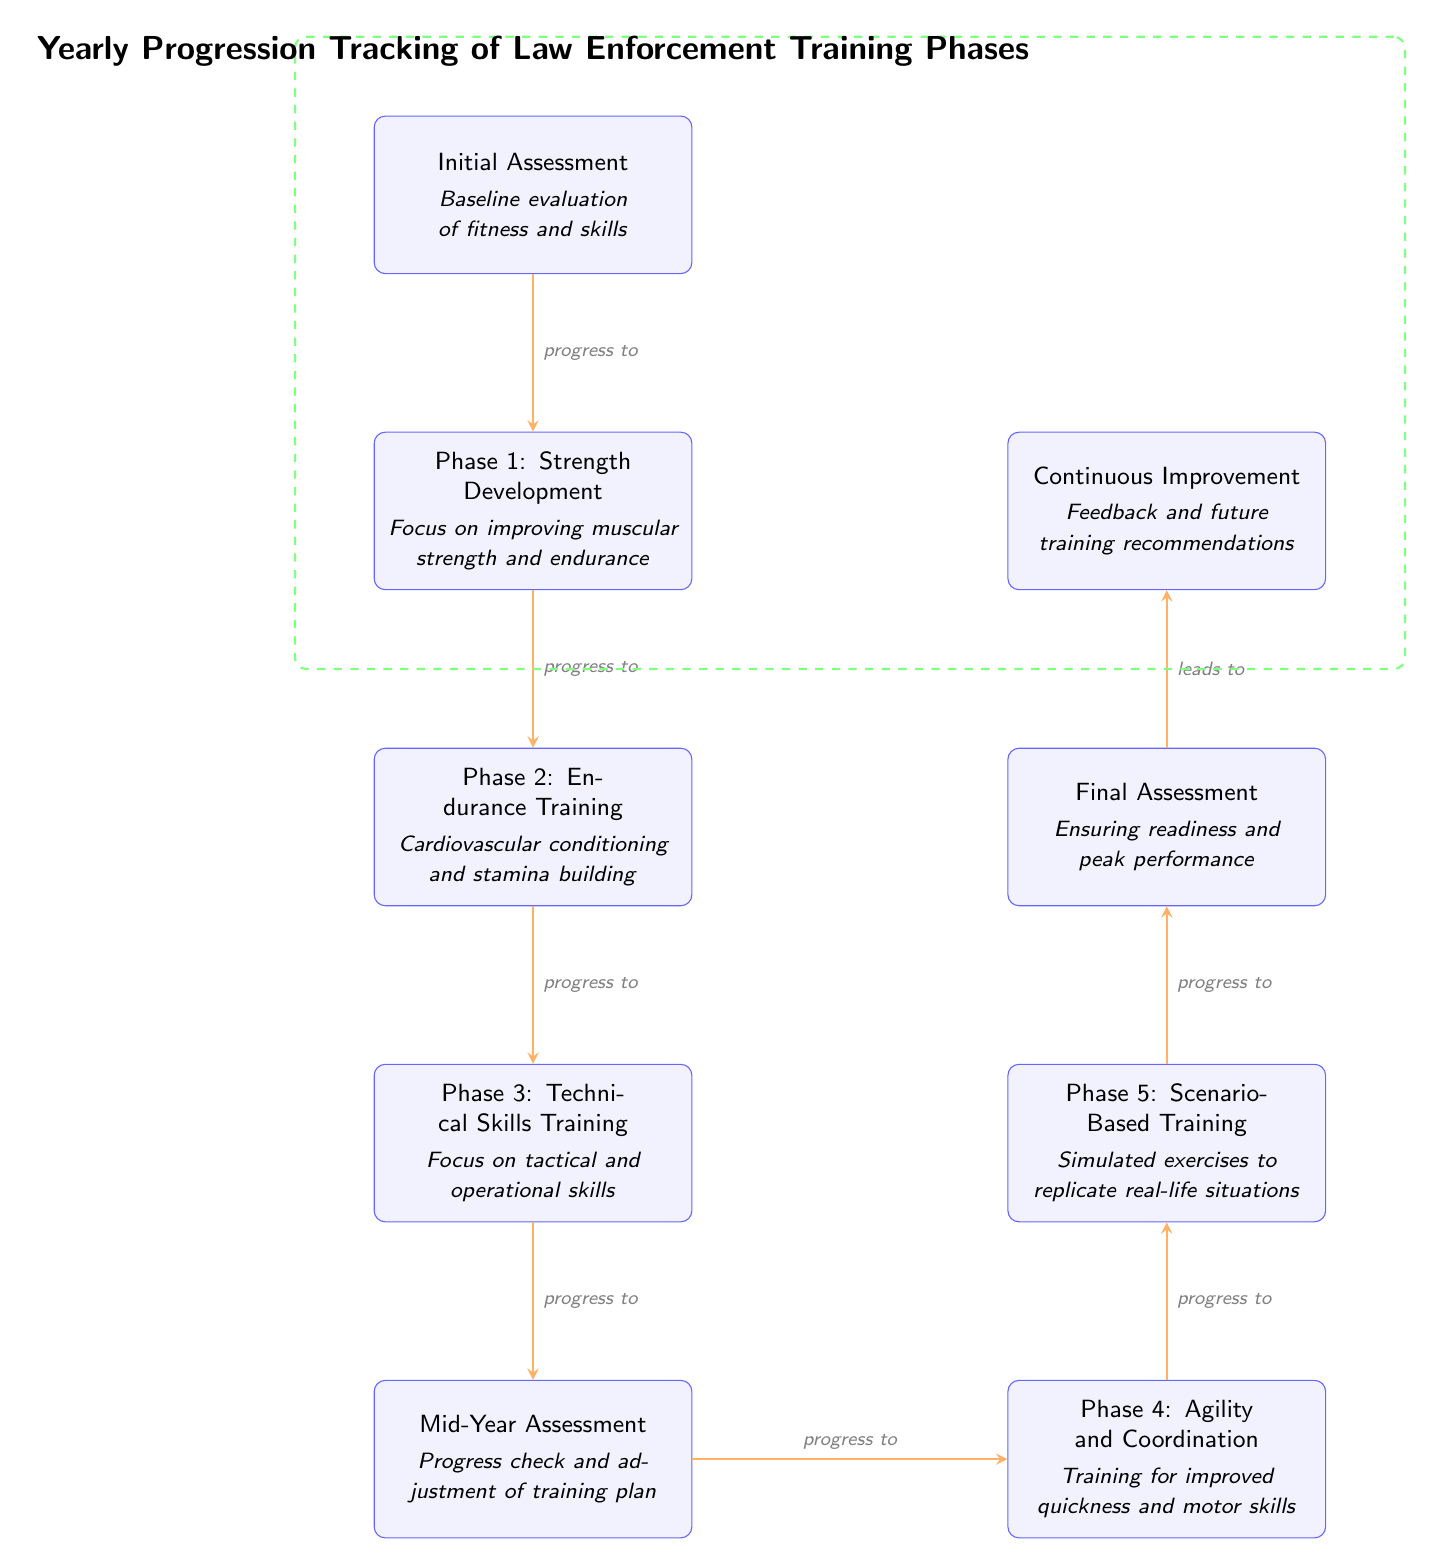What's the first phase of training? The diagram starts with the "Initial Assessment," which provides the baseline evaluation. The first phase listed in terms of training is actually "Phase 1: Strength Development."
Answer: Phase 1: Strength Development How many main phases of training are there? The diagram lists five distinct training phases before the assessments, suggesting there are five primary phases.
Answer: Five What is the purpose of the Mid-Year Assessment? The Mid-Year Assessment is a progress check designed to evaluate adjustments in the training plan. This is noted in the diagram.
Answer: Progress check and adjustment of training plan Which phase follows the Technical Skills Training? In the progression, after "Phase 3: Technical Skills Training," the next node is the "Mid-Year Assessment." This indicates the order of training phases and assessments.
Answer: Mid-Year Assessment What training phase specifically focuses on tactical and operational skills? Based on the diagram, "Phase 3: Technical Skills Training" is specifically highlighted as focusing on tactical and operational skills for law enforcement personnel.
Answer: Phase 3: Technical Skills Training What leads to Continuous Improvement? The arrow connecting "Final Assessment" to "Continuous Improvement" shows that the completion of the final assessment leads into continuous improvement for future training recommendations.
Answer: Final Assessment Which phase addresses agility and coordination? The diagram clearly labels "Phase 4: Agility and Coordination," indicating this phase is specifically set to improve quickness and motor skills.
Answer: Phase 4: Agility and Coordination What is the last step in the yearly progression diagram? The last step outlined in the diagram is "Continuous Improvement," indicating the final focus after assessing readiness and peak performance.
Answer: Continuous Improvement 